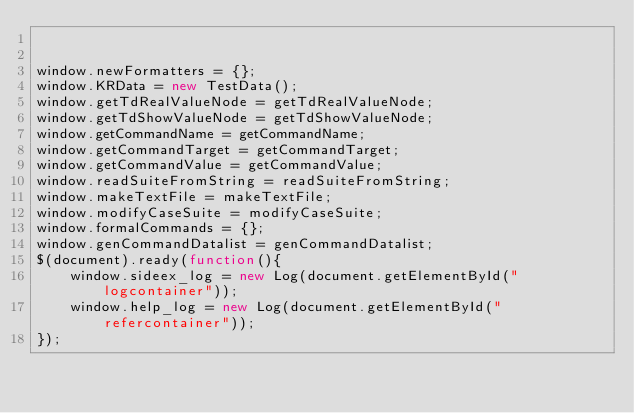<code> <loc_0><loc_0><loc_500><loc_500><_JavaScript_>

window.newFormatters = {};
window.KRData = new TestData();
window.getTdRealValueNode = getTdRealValueNode;
window.getTdShowValueNode = getTdShowValueNode;
window.getCommandName = getCommandName;
window.getCommandTarget = getCommandTarget;
window.getCommandValue = getCommandValue;
window.readSuiteFromString = readSuiteFromString;
window.makeTextFile = makeTextFile;
window.modifyCaseSuite = modifyCaseSuite;
window.formalCommands = {};
window.genCommandDatalist = genCommandDatalist;
$(document).ready(function(){
    window.sideex_log = new Log(document.getElementById("logcontainer"));
    window.help_log = new Log(document.getElementById("refercontainer"));
});





</code> 